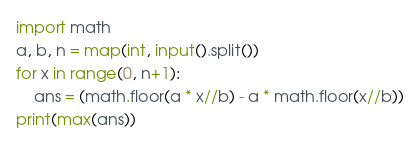Convert code to text. <code><loc_0><loc_0><loc_500><loc_500><_Python_>import math
a, b, n = map(int, input().split())
for x in range(0, n+1):
    ans = (math.floor(a * x//b) - a * math.floor(x//b))
print(max(ans))</code> 